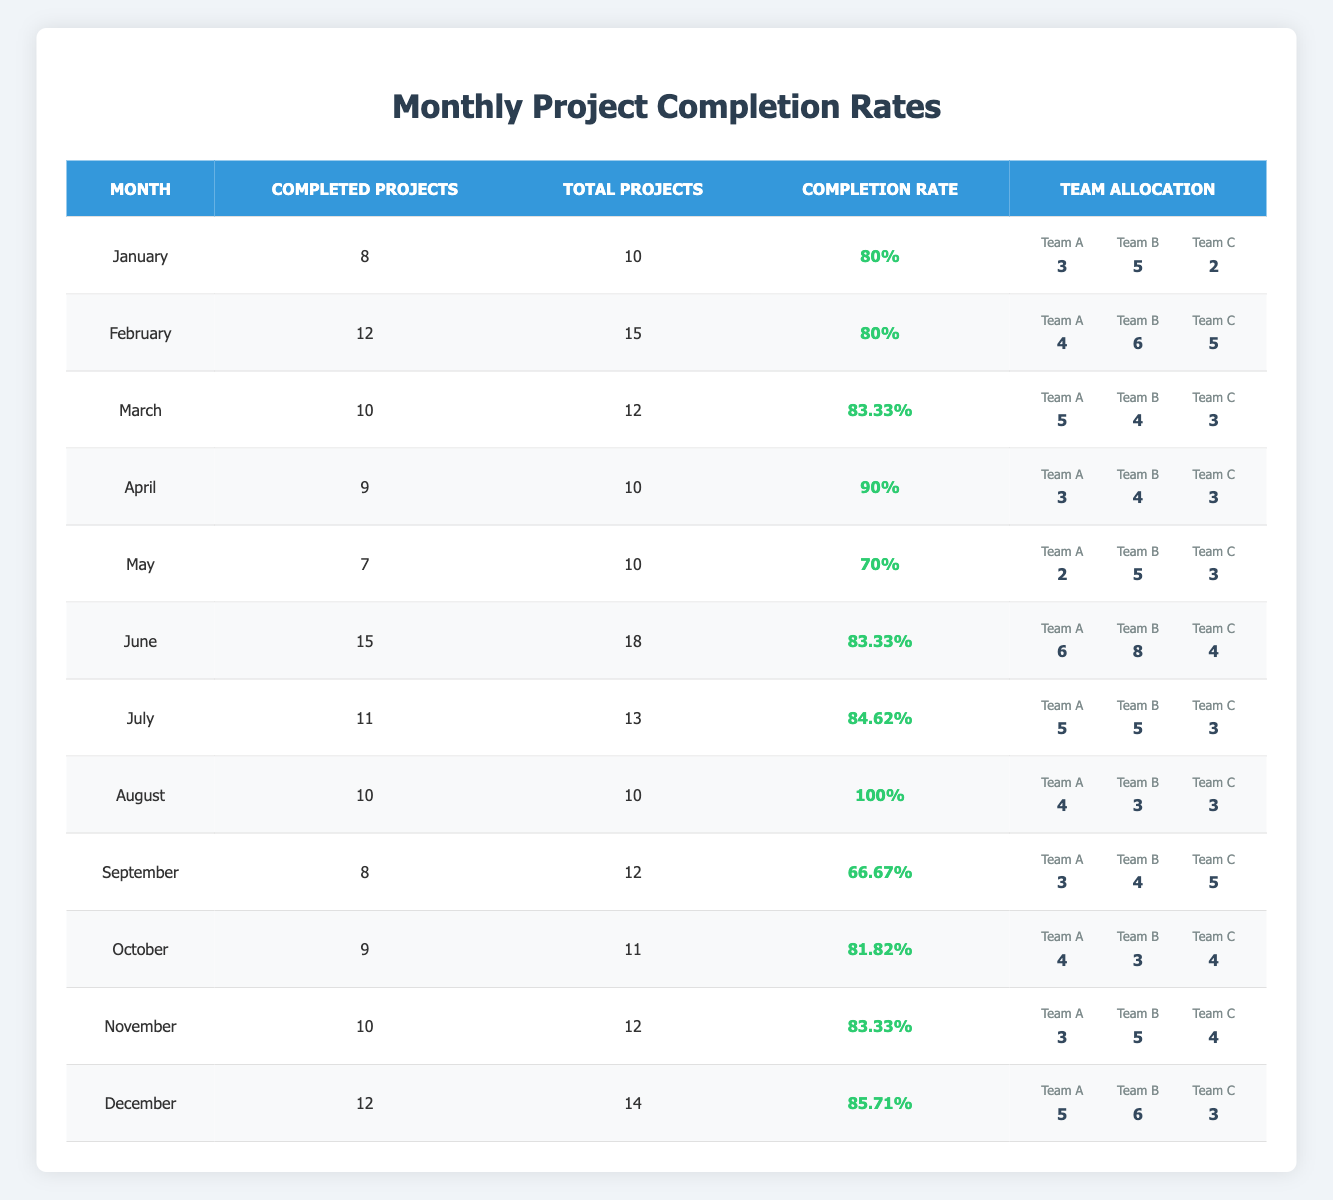What was the completion rate in August? The completion rate for August is directly mentioned in the table under the corresponding month. It states that the completion rate for August is 100%.
Answer: 100% Which month had the highest number of completed projects? The highest number of completed projects is found in June, where 15 projects were completed. By comparing all completed projects for each month, June has the highest value.
Answer: June How many projects were completed in total from January to March? To find the total completed projects from January to March, we must sum the completed projects for each of these months: January (8) + February (12) + March (10) = 30.
Answer: 30 Did Team A contribute more than Team C in completed projects for April? In April, Team A completed 3 projects while Team C completed 3 projects as well. Since they both contributed the same number of projects, the answer is false.
Answer: No What is the average completion rate from January to March? To find the average completion rate for January (80), February (80), and March (83.33), we add them up (80 + 80 + 83.33 = 243.33) and then divide by the number of months (3). The average is approximately 81.11.
Answer: 81.11 Which team had the highest allocation in June? In June, Team B had the highest allocation with 8 members assigned to projects. Comparing allocations of Team A (6), Team B (8), and Team C (4), Team B is the highest.
Answer: Team B What was the completion rate for the month with the least total projects? The month with the least total projects is May, where 10 total projects were designated, and the completion rate was 70%. If we check the data for May, it confirms this information.
Answer: 70% Which months had a completion rate below 80%? The completion rates below 80% can be found by comparing each month's rate. September (66.67) and May (70) are below 80%. Therefore, those are the months with lower rates.
Answer: September, May In which month did the total projects exceed the completed projects by the most? To find the month with the greatest difference between total projects and completed projects, we can calculate the difference for each month. April (1), October (2), September (4), and May (3) show differences, but September has the highest at 4.
Answer: September 